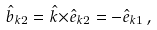<formula> <loc_0><loc_0><loc_500><loc_500>\hat { b } _ { { k } 2 } = { \hat { k } } { \times } \hat { e } _ { { k } 2 } = - \hat { e } _ { { k } 1 } \, ,</formula> 